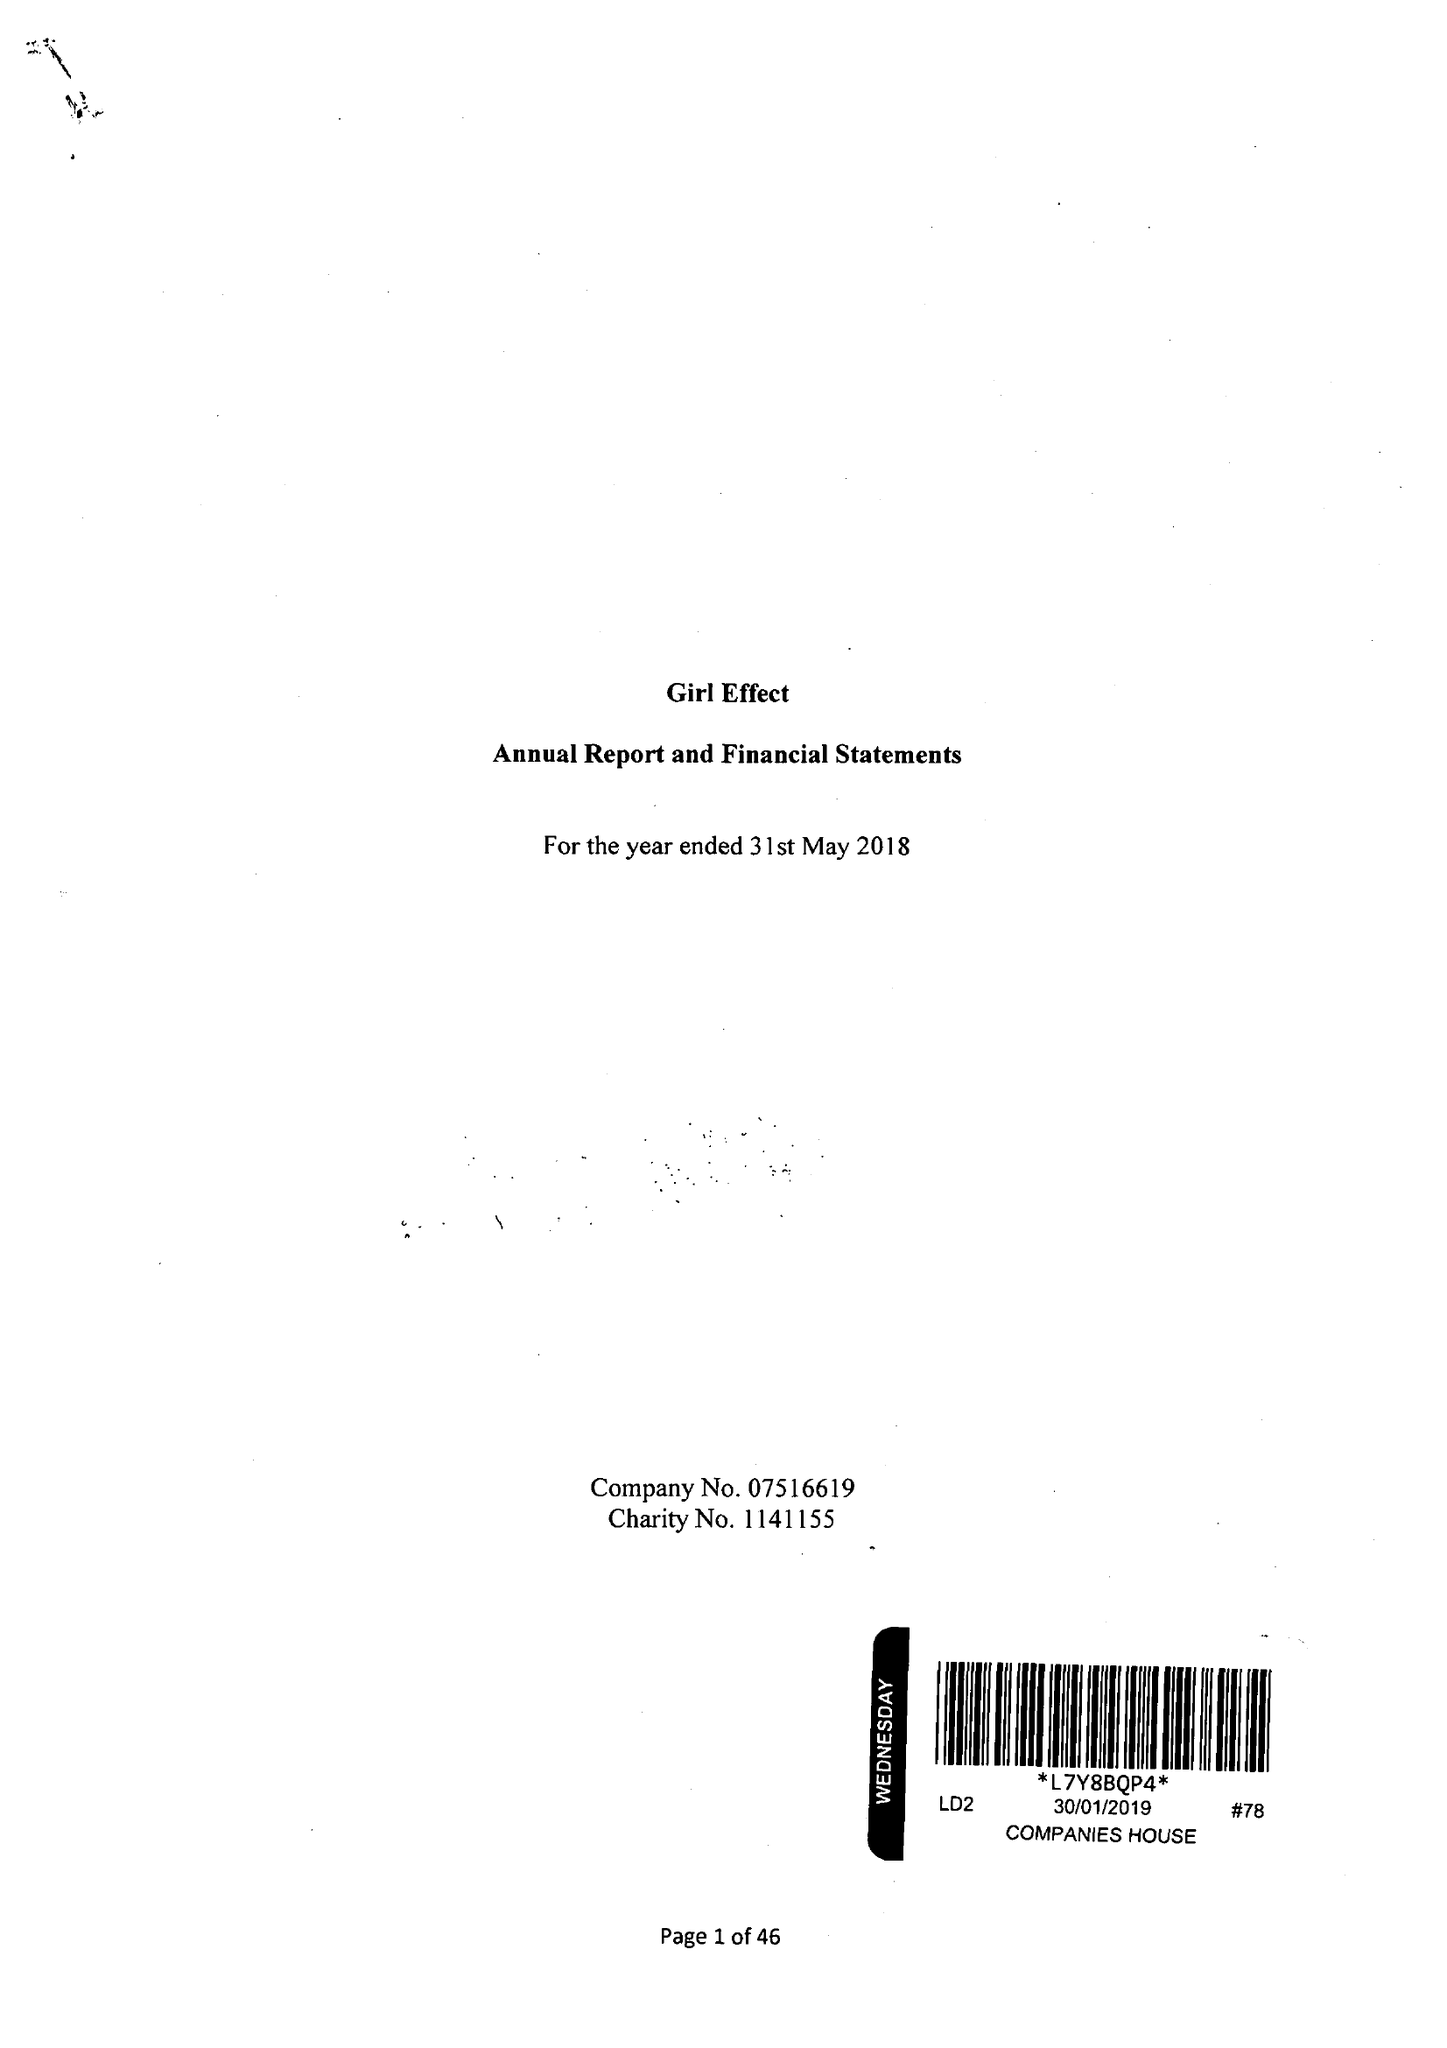What is the value for the charity_name?
Answer the question using a single word or phrase. Girl Effect 